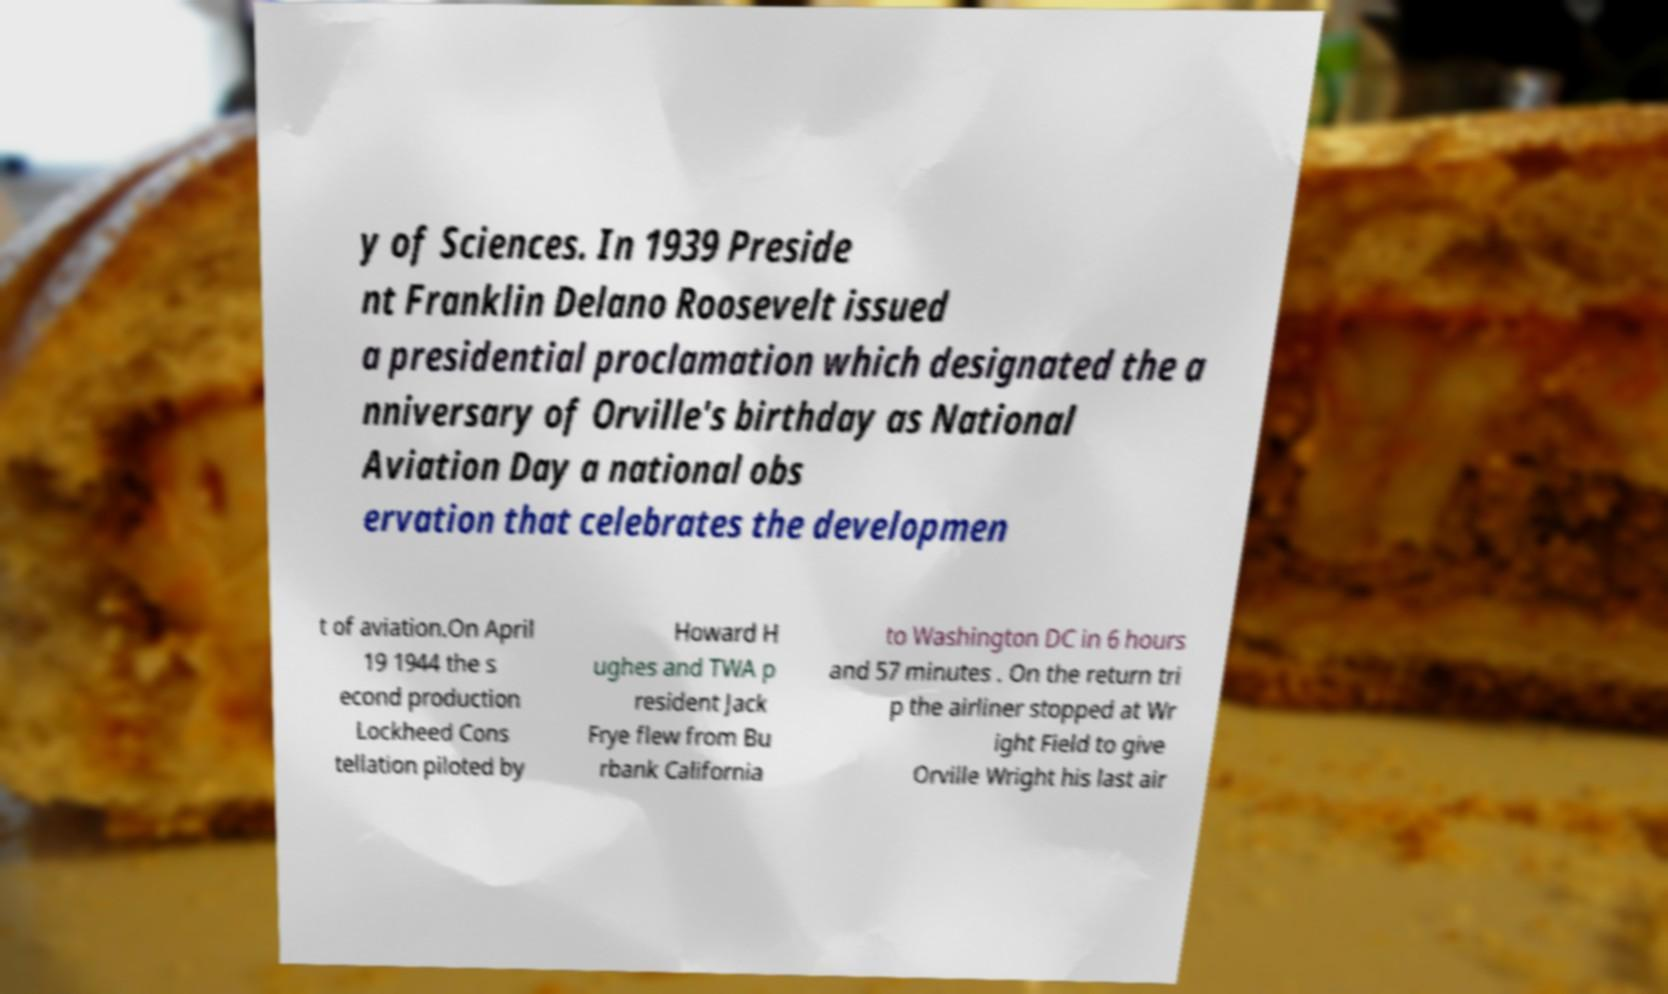Please read and relay the text visible in this image. What does it say? y of Sciences. In 1939 Preside nt Franklin Delano Roosevelt issued a presidential proclamation which designated the a nniversary of Orville's birthday as National Aviation Day a national obs ervation that celebrates the developmen t of aviation.On April 19 1944 the s econd production Lockheed Cons tellation piloted by Howard H ughes and TWA p resident Jack Frye flew from Bu rbank California to Washington DC in 6 hours and 57 minutes . On the return tri p the airliner stopped at Wr ight Field to give Orville Wright his last air 